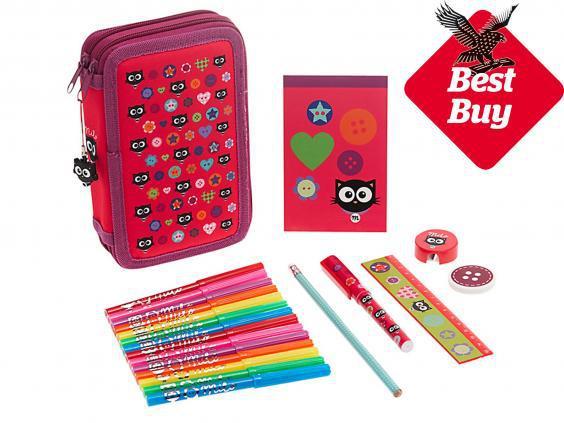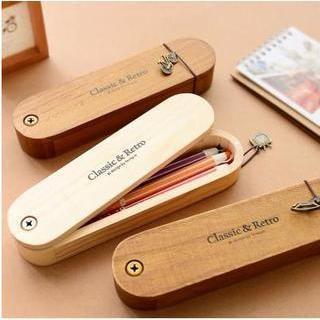The first image is the image on the left, the second image is the image on the right. For the images displayed, is the sentence "A hand is opening a pencil case in the right image." factually correct? Answer yes or no. No. 